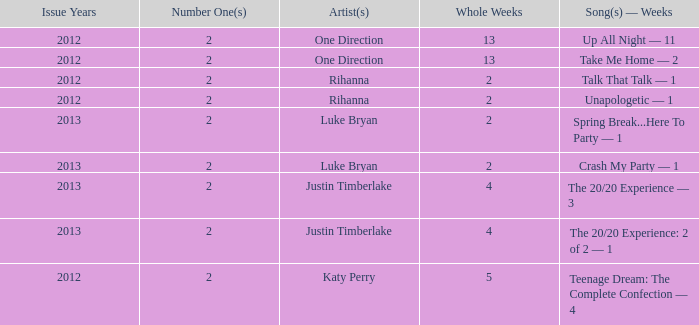What is the longest number of weeks any 1 song was at number #1? 13.0. 